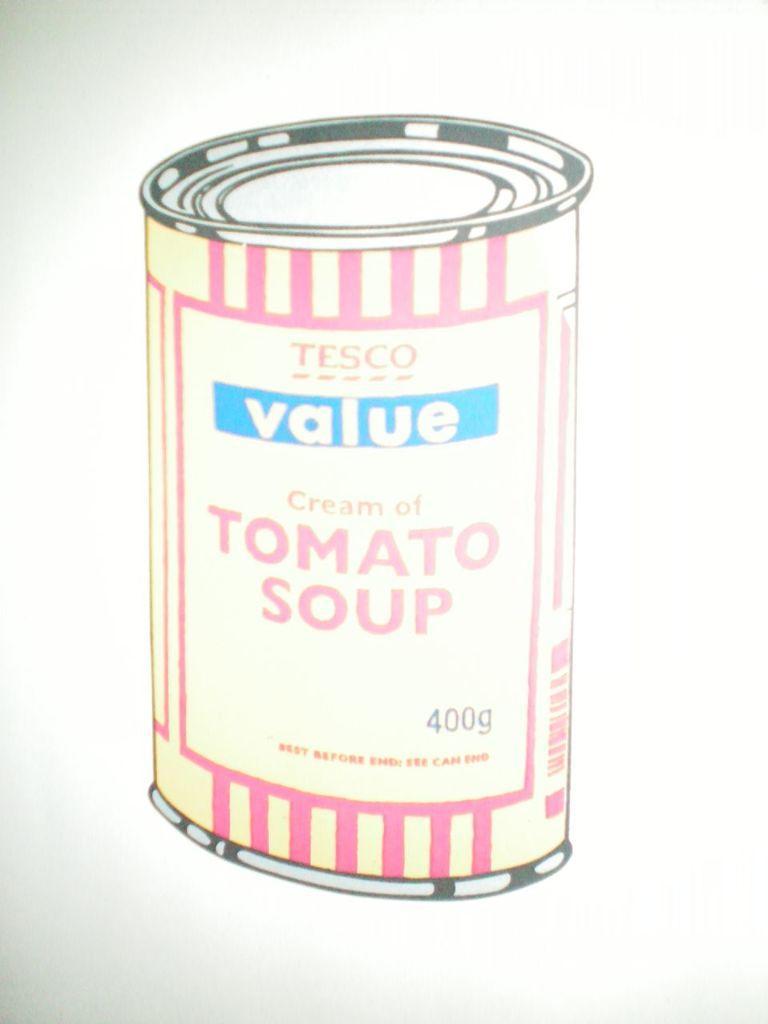Please provide a concise description of this image. In this picture there is a poster. On the poster i can see the can. 